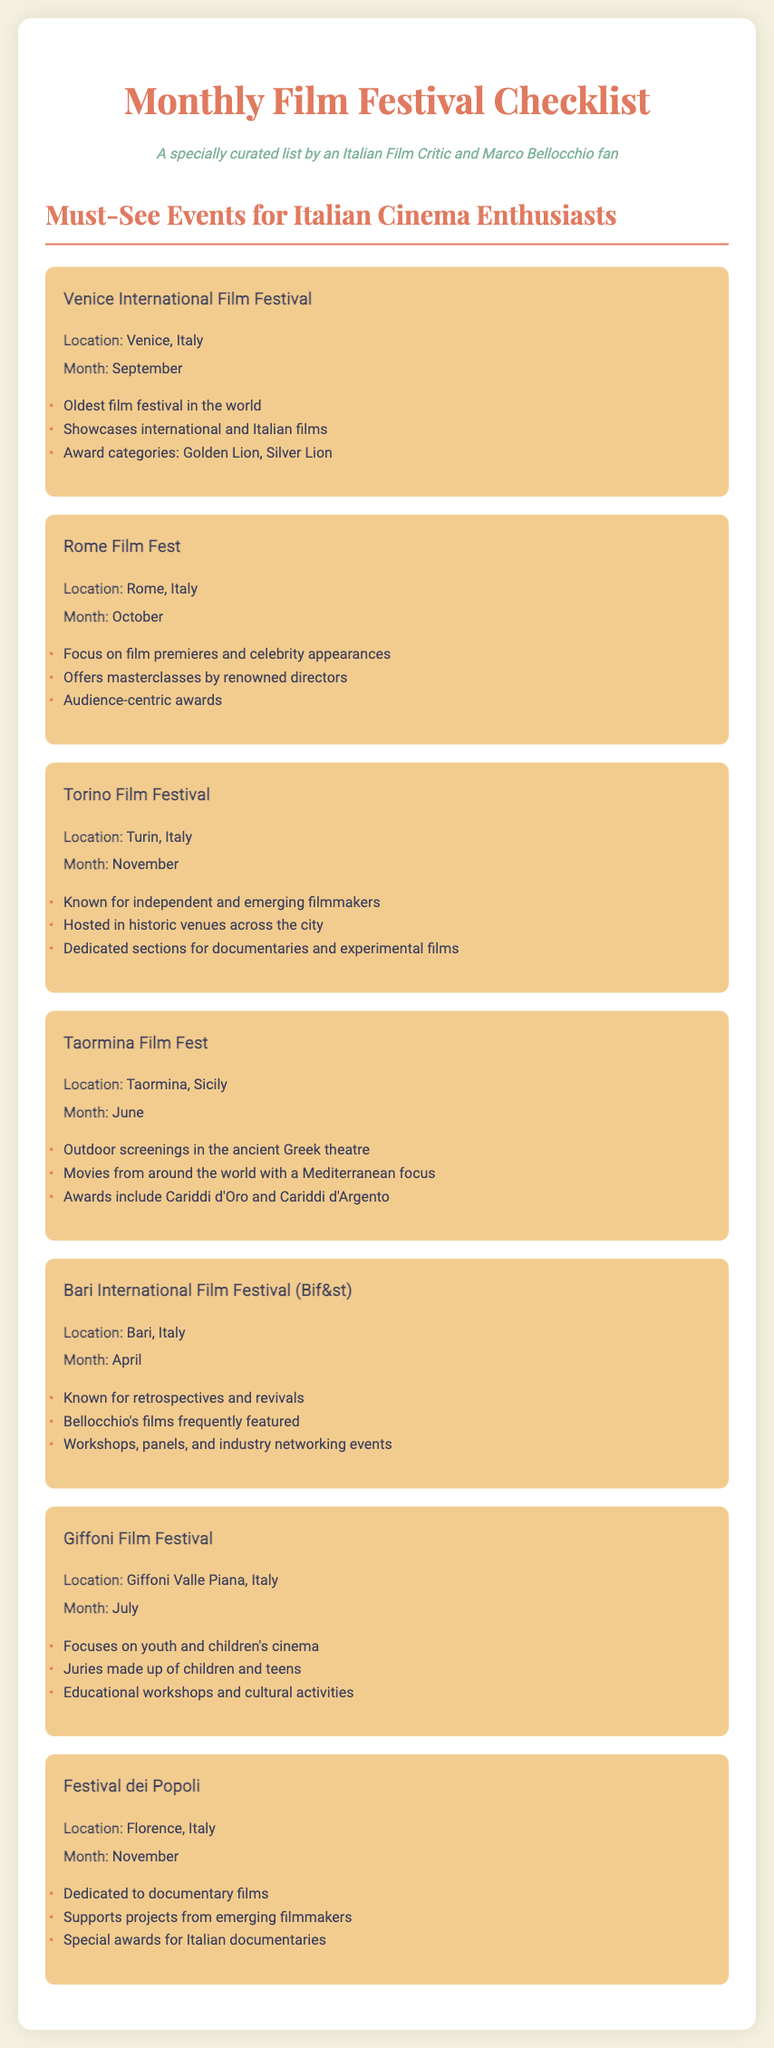What month is the Venice International Film Festival held? The document states that the Venice International Film Festival is held in September.
Answer: September What award is given at the Rome Film Fest? The document lists that audience-centric awards are given at the Rome Film Fest.
Answer: Audience-centric awards Which festival focuses on independent filmmakers? The Torino Film Festival is known for featuring independent and emerging filmmakers.
Answer: Torino Film Festival What is a notable feature of the Taormina Film Fest? The document mentions outdoor screenings in the ancient Greek theatre as a notable feature.
Answer: Outdoor screenings in the ancient Greek theatre How often does the Bari International Film Festival occur? The document doesn't explicitly state frequency, but implies it happens annually in April.
Answer: Annually What kind of cinema does the Giffoni Film Festival focus on? The Giffoni Film Festival is focused on youth and children's cinema.
Answer: Youth and children's cinema Which festival had Bellocchio's films frequently featured? The Bari International Film Festival (Bif&st) is known for featuring Bellocchio's films.
Answer: Bari International Film Festival (Bif&st) What type of films does the Festival dei Popoli showcase? The document indicates that the Festival dei Popoli is dedicated to documentary films.
Answer: Documentary films 